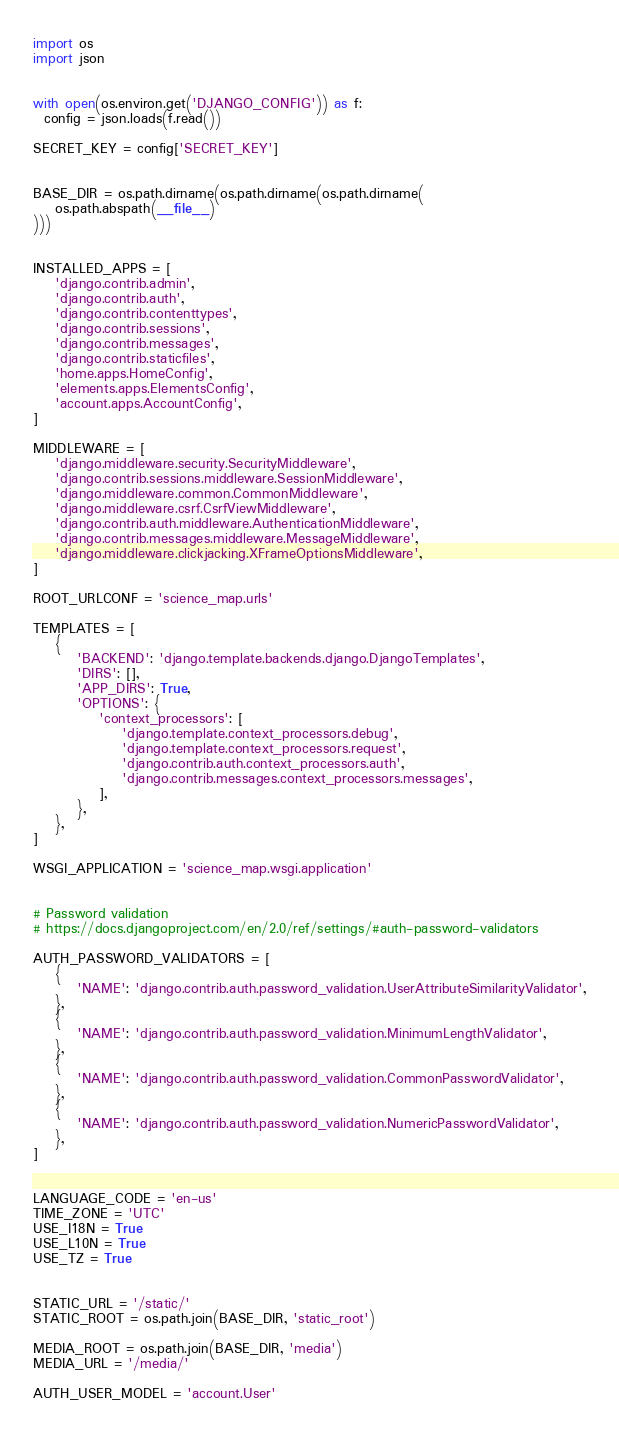Convert code to text. <code><loc_0><loc_0><loc_500><loc_500><_Python_>import os
import json


with open(os.environ.get('DJANGO_CONFIG')) as f:
  config = json.loads(f.read())

SECRET_KEY = config['SECRET_KEY']


BASE_DIR = os.path.dirname(os.path.dirname(os.path.dirname(
    os.path.abspath(__file__)
)))


INSTALLED_APPS = [
    'django.contrib.admin',
    'django.contrib.auth',
    'django.contrib.contenttypes',
    'django.contrib.sessions',
    'django.contrib.messages',
    'django.contrib.staticfiles',
    'home.apps.HomeConfig',
    'elements.apps.ElementsConfig',
    'account.apps.AccountConfig',
]

MIDDLEWARE = [
    'django.middleware.security.SecurityMiddleware',
    'django.contrib.sessions.middleware.SessionMiddleware',
    'django.middleware.common.CommonMiddleware',
    'django.middleware.csrf.CsrfViewMiddleware',
    'django.contrib.auth.middleware.AuthenticationMiddleware',
    'django.contrib.messages.middleware.MessageMiddleware',
    'django.middleware.clickjacking.XFrameOptionsMiddleware',
]

ROOT_URLCONF = 'science_map.urls'

TEMPLATES = [
    {
        'BACKEND': 'django.template.backends.django.DjangoTemplates',
        'DIRS': [],
        'APP_DIRS': True,
        'OPTIONS': {
            'context_processors': [
                'django.template.context_processors.debug',
                'django.template.context_processors.request',
                'django.contrib.auth.context_processors.auth',
                'django.contrib.messages.context_processors.messages',
            ],
        },
    },
]

WSGI_APPLICATION = 'science_map.wsgi.application'


# Password validation
# https://docs.djangoproject.com/en/2.0/ref/settings/#auth-password-validators

AUTH_PASSWORD_VALIDATORS = [
    {
        'NAME': 'django.contrib.auth.password_validation.UserAttributeSimilarityValidator',
    },
    {
        'NAME': 'django.contrib.auth.password_validation.MinimumLengthValidator',
    },
    {
        'NAME': 'django.contrib.auth.password_validation.CommonPasswordValidator',
    },
    {
        'NAME': 'django.contrib.auth.password_validation.NumericPasswordValidator',
    },
]


LANGUAGE_CODE = 'en-us'
TIME_ZONE = 'UTC'
USE_I18N = True
USE_L10N = True
USE_TZ = True


STATIC_URL = '/static/'
STATIC_ROOT = os.path.join(BASE_DIR, 'static_root')

MEDIA_ROOT = os.path.join(BASE_DIR, 'media')
MEDIA_URL = '/media/'

AUTH_USER_MODEL = 'account.User'
</code> 